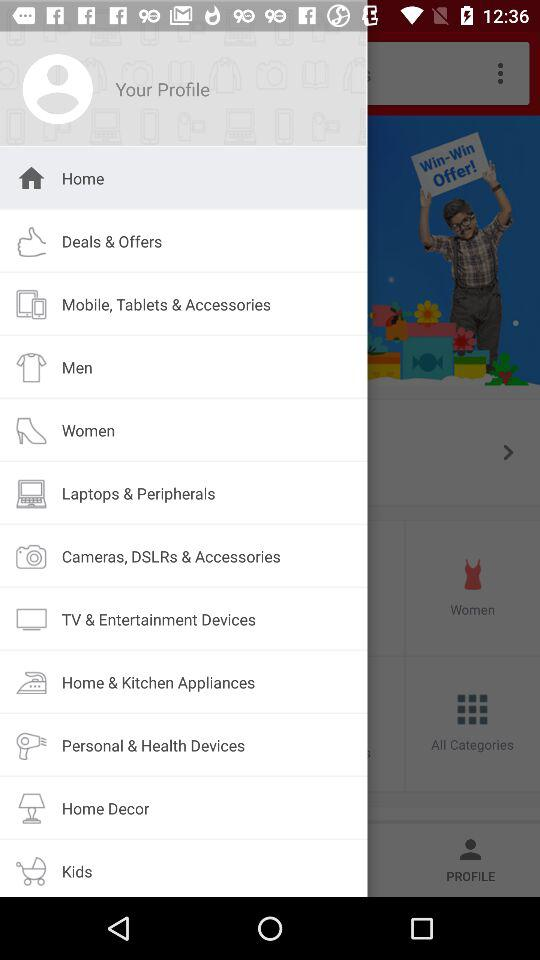Which item is currently selected? The currently selected item is "Home". 